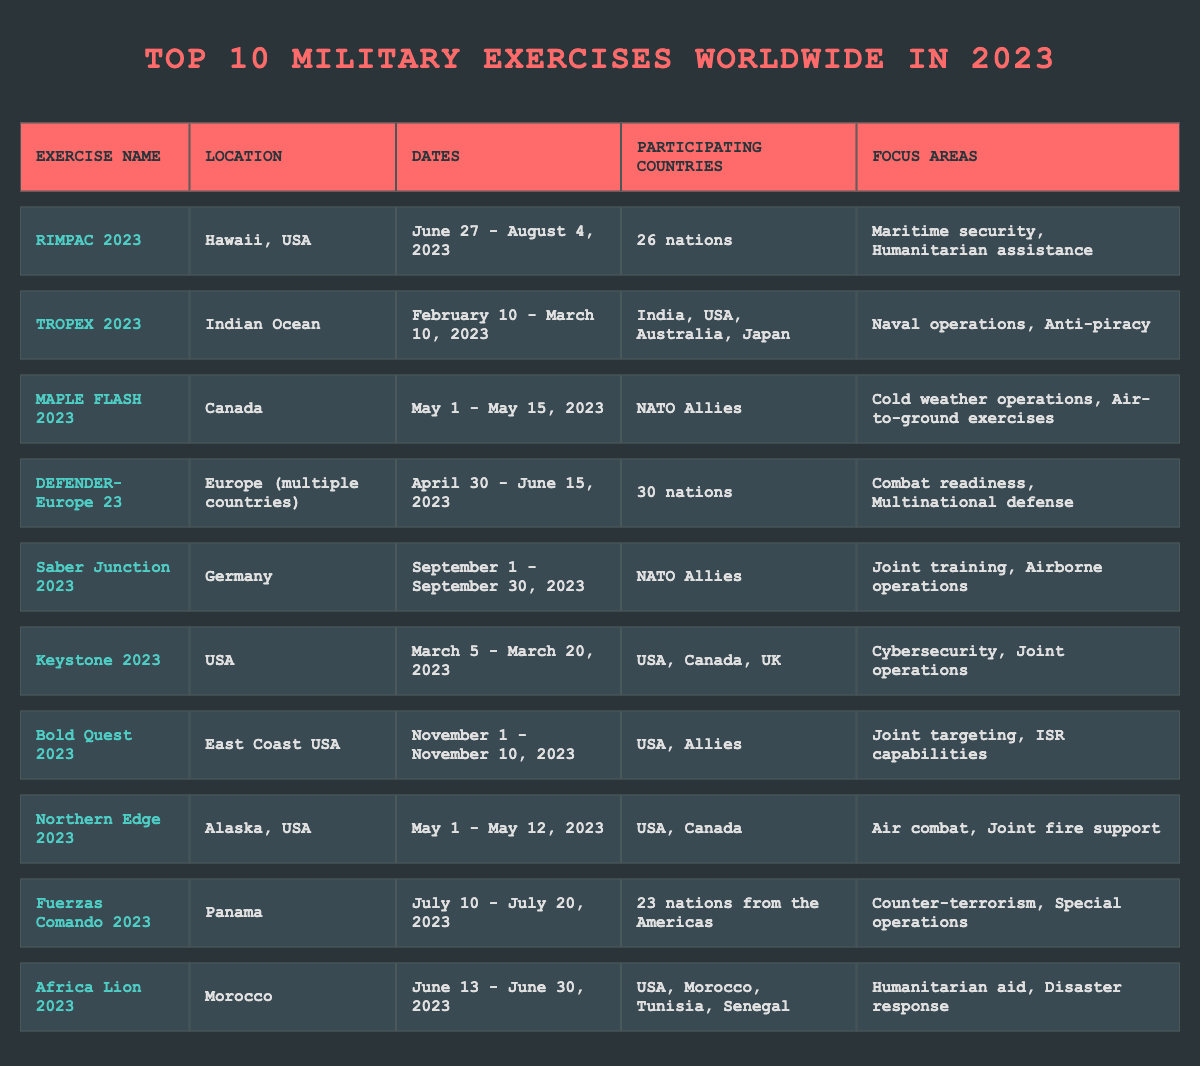What is the location of RIMPAC 2023? The table specifies the location of RIMPAC 2023 as bolded text in the "Location" column, which reads "Hawaii, USA."
Answer: Hawaii, USA How many nations participated in DEFENDER-Europe 23? Looking at the "Participating Countries" column for DEFENDER-Europe 23, it shows "30 nations."
Answer: 30 nations Which military exercise took place in Germany? The exercise listed in the table with a location of Germany is "Saber Junction 2023," found in the "Location" column.
Answer: Saber Junction 2023 What focus areas are highlighted for Africa Lion 2023? In the "Focus Areas" column for Africa Lion 2023, it describes the areas as "Humanitarian aid, Disaster response."
Answer: Humanitarian aid, Disaster response Which exercises focused on joint operations? By scanning the "Focus Areas" column, both Keystone 2023 and Bold Quest 2023 mention joint operations. Keystone 2023 highlights "Cybersecurity, Joint operations," and Bold Quest 2023 highlights "Joint targeting, ISR capabilities."
Answer: Keystone 2023 and Bold Quest 2023 Is there any exercise focused exclusively on maritime security? The table indicates that RIMPAC 2023 focuses on "Maritime security, Humanitarian assistance," suggesting it includes maritime security but does not state it is exclusive to this focus.
Answer: No How many nations participated in the Southern exercises (TROPEX 2023 and Fuerzas Comando 2023)? TROPEX 2023 involved 4 nations, while Fuerzas Comando 2023 involved 23 nations.Therefore, adding these gives us 4 + 23 = 27.
Answer: 27 What is the total number of exercises that took place in the Americas? According to the table, both RIMPAC 2023 (Hawaii, USA) and Fuerzas Comando 2023 (Panama) are listed as exercises in the Americas. Thus, there are 2 exercises in total.
Answer: 2 What was the duration of the Saber Junction 2023 exercise? The table indicates the dates for Saber Junction 2023 as "September 1 - September 30, 2023." Calculating the total gives us 30 days.
Answer: 30 days Which exercise had the most diverse international participation? DEFENDER-Europe 23 is noted for involving "30 nations," which is the highest number among all listed exercises.
Answer: DEFENDER-Europe 23 How many exercises took place in May 2023? The table lists three exercises that occurred in May: MAPLE FLASH 2023, Northern Edge 2023, and the start of DEFENDER-Europe 23. Therefore, the count is 3.
Answer: 3 